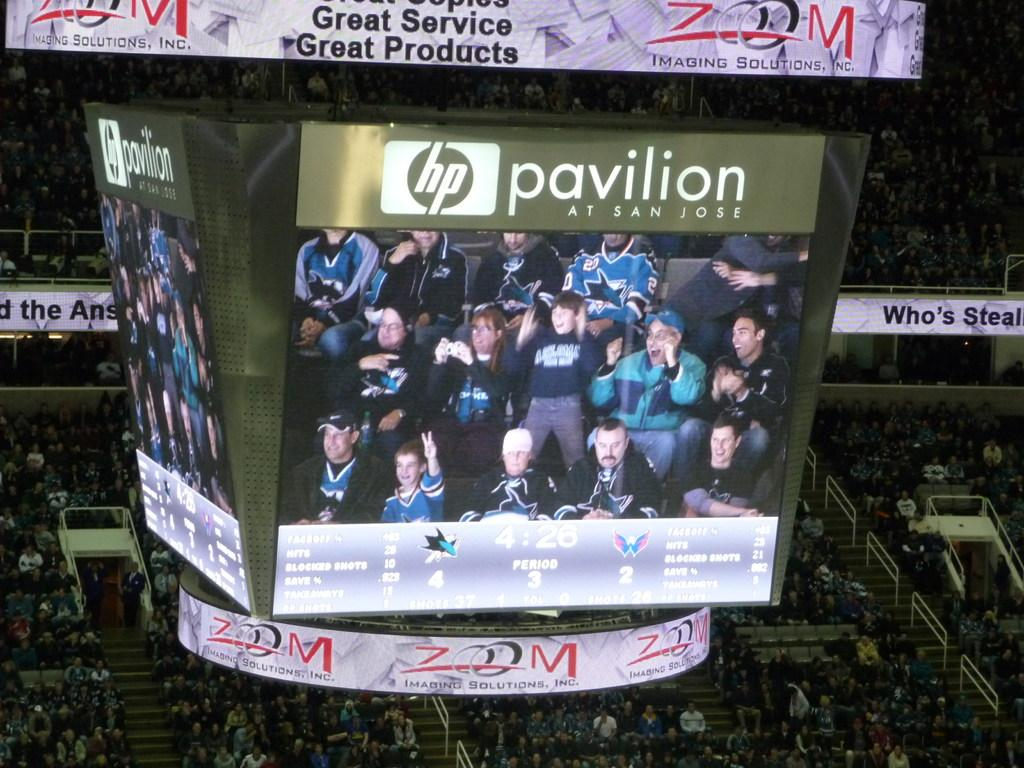<image>
Relay a brief, clear account of the picture shown. HP Pavilion jumbo screen at San Jose that shows a fan crowd. 